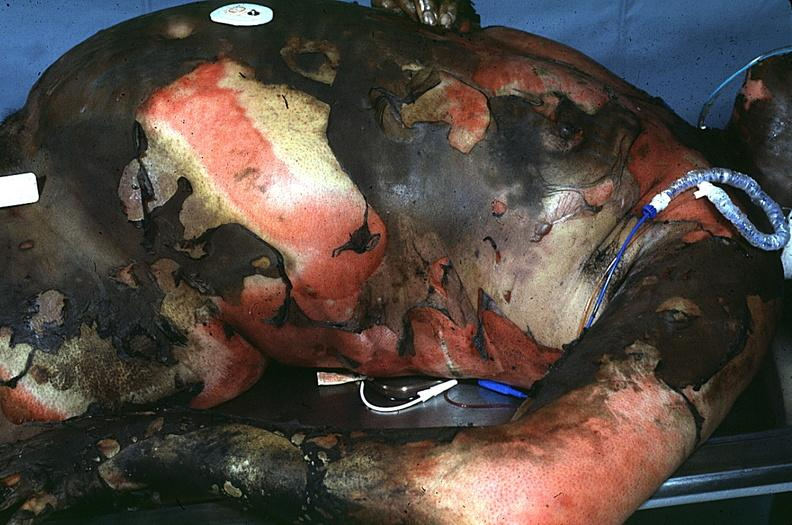what does this image show?
Answer the question using a single word or phrase. Thermal burn 